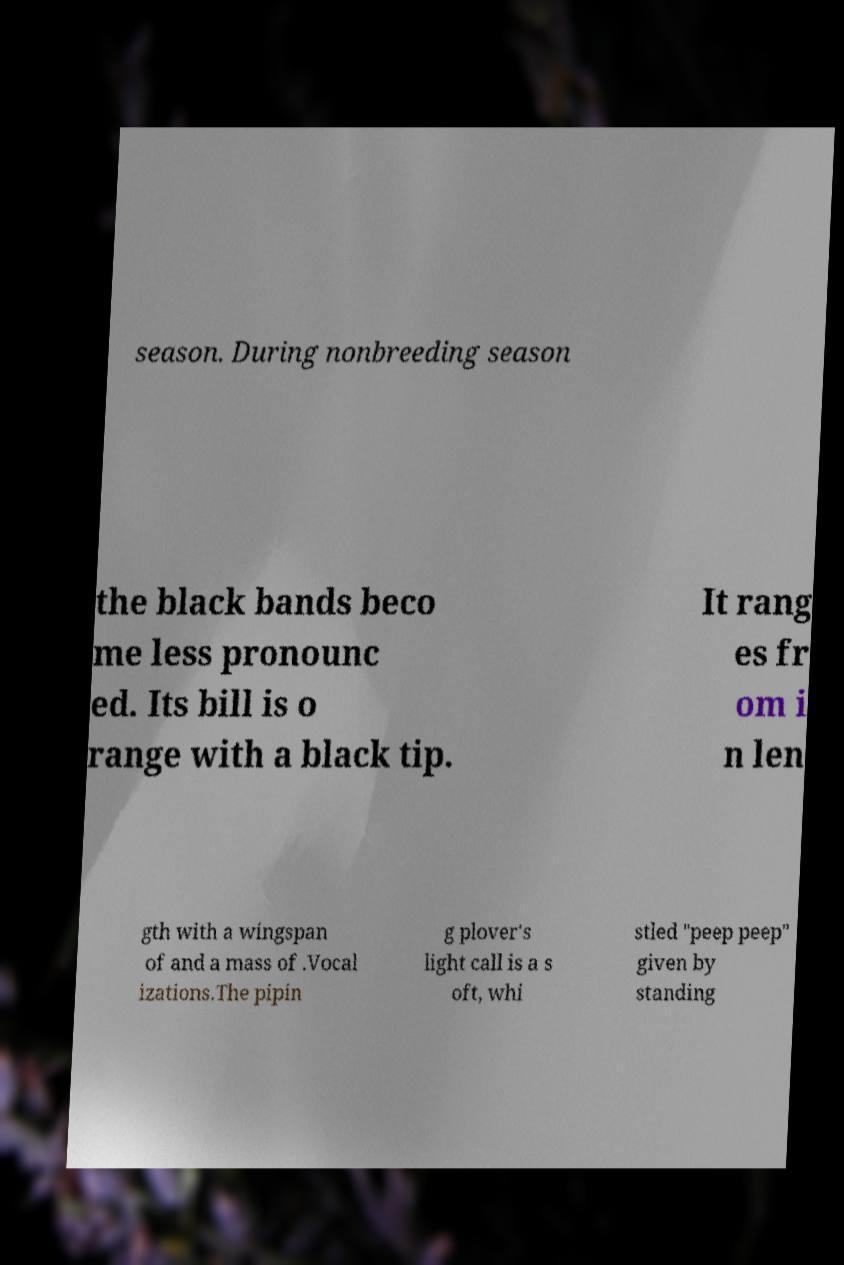Could you assist in decoding the text presented in this image and type it out clearly? season. During nonbreeding season the black bands beco me less pronounc ed. Its bill is o range with a black tip. It rang es fr om i n len gth with a wingspan of and a mass of .Vocal izations.The pipin g plover's light call is a s oft, whi stled "peep peep" given by standing 